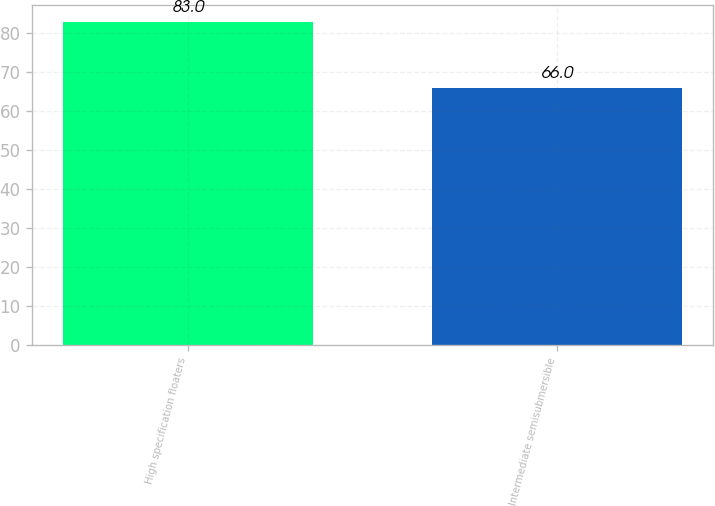Convert chart to OTSL. <chart><loc_0><loc_0><loc_500><loc_500><bar_chart><fcel>High specification floaters<fcel>Intermediate semisubmersible<nl><fcel>83<fcel>66<nl></chart> 